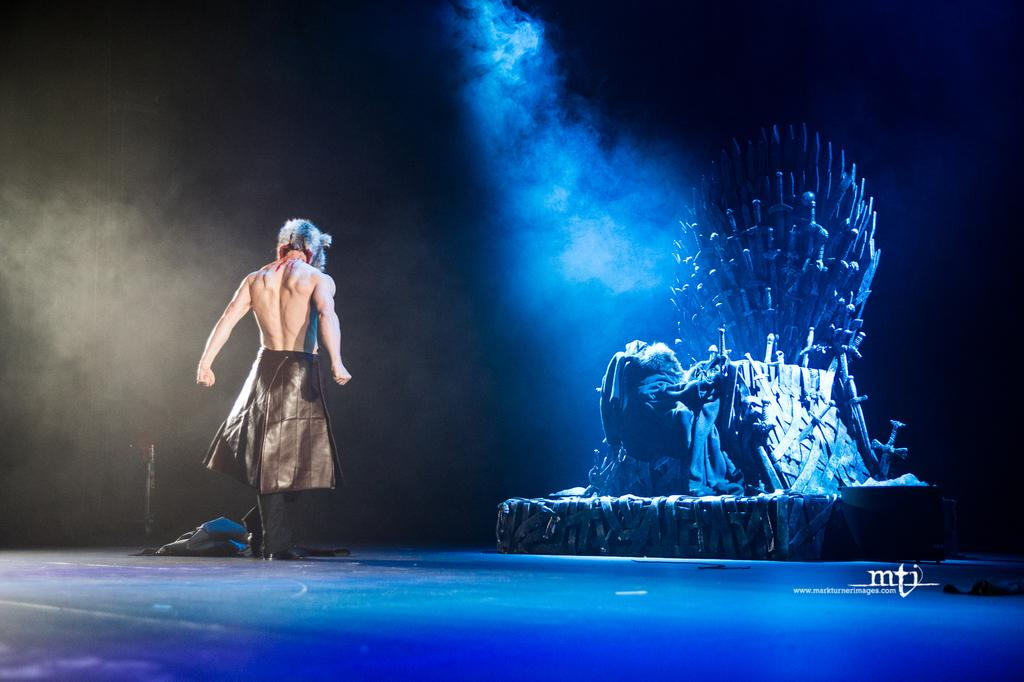What is the main subject of the image? The main subject of the image is a man on the stage. Can you describe any objects in the image? Yes, there is a chair in the image. What is the color of the background in the image? The background of the image is dark. What type of line can be seen connecting the man and the chair in the image? There is no line connecting the man and the chair in the image. What type of wax is being used by the man on the stage in the image? There is no wax present in the image. What type of pest can be seen crawling on the stage in the image? There is no pest present in the image. 